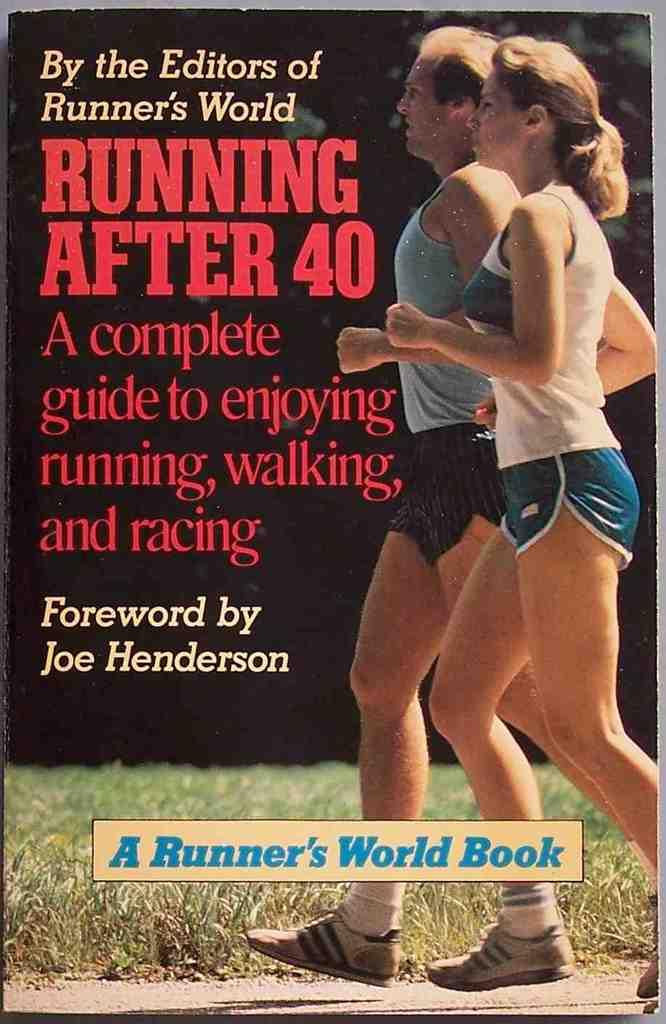Provide a one-sentence caption for the provided image. A Runner's World book about running after 40. 